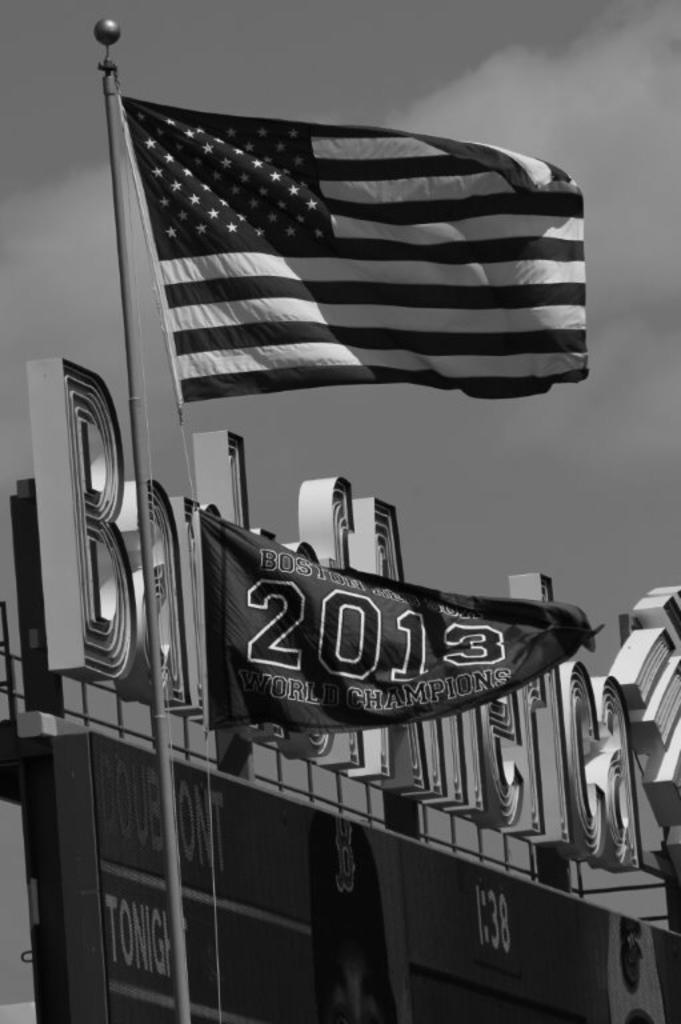<image>
Render a clear and concise summary of the photo. On the pole beneath the American flag is another stating Boston team was the 2013 champion. 